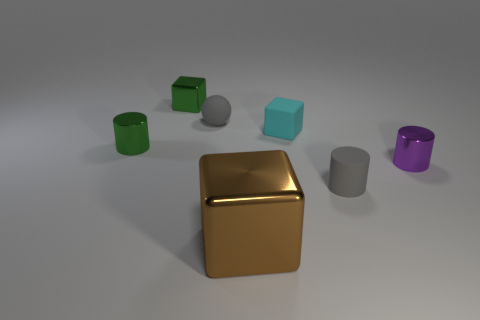Is there anything else that is the same size as the brown object?
Offer a terse response. No. How many tiny green objects are the same material as the brown block?
Offer a terse response. 2. What is the shape of the shiny thing that is both on the left side of the large shiny cube and in front of the tiny green cube?
Provide a succinct answer. Cylinder. What number of things are small green metallic things that are behind the tiny gray rubber sphere or shiny things that are to the left of the purple cylinder?
Provide a succinct answer. 3. Are there the same number of small gray spheres in front of the purple metal thing and big brown metallic cubes behind the cyan matte object?
Your response must be concise. Yes. What shape is the green object that is on the right side of the green metal thing in front of the gray rubber sphere?
Your answer should be compact. Cube. Is there a tiny gray matte thing of the same shape as the brown thing?
Offer a terse response. No. How many small shiny things are there?
Provide a succinct answer. 3. Is the material of the green thing behind the tiny rubber block the same as the large brown thing?
Your answer should be very brief. Yes. Are there any other gray matte spheres that have the same size as the sphere?
Your answer should be very brief. No. 